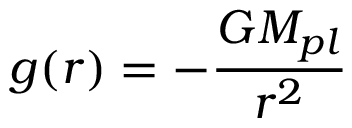Convert formula to latex. <formula><loc_0><loc_0><loc_500><loc_500>g ( r ) = - \frac { G M _ { p l } } { r ^ { 2 } }</formula> 